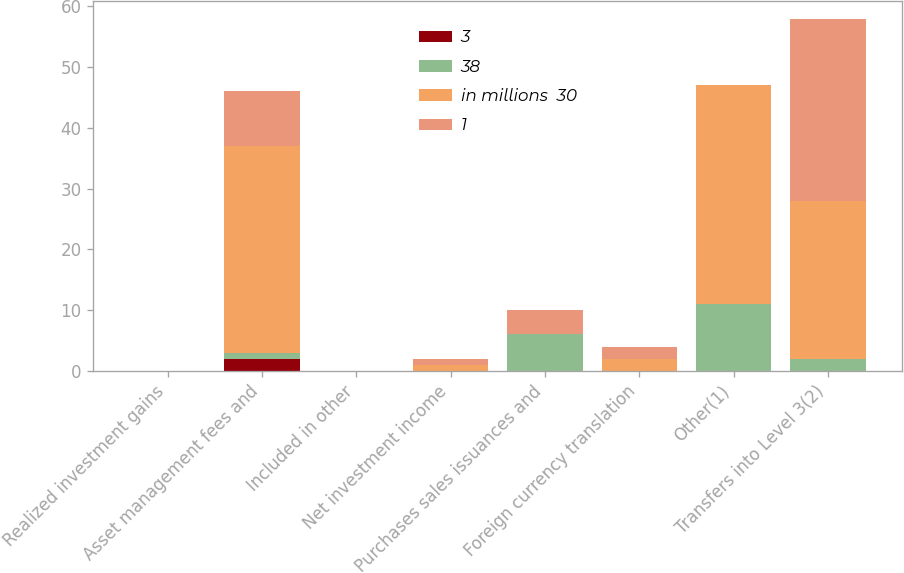Convert chart to OTSL. <chart><loc_0><loc_0><loc_500><loc_500><stacked_bar_chart><ecel><fcel>Realized investment gains<fcel>Asset management fees and<fcel>Included in other<fcel>Net investment income<fcel>Purchases sales issuances and<fcel>Foreign currency translation<fcel>Other(1)<fcel>Transfers into Level 3(2)<nl><fcel>3<fcel>0<fcel>2<fcel>0<fcel>0<fcel>0<fcel>0<fcel>0<fcel>0<nl><fcel>38<fcel>0<fcel>1<fcel>0<fcel>0<fcel>6<fcel>0<fcel>11<fcel>2<nl><fcel>in millions  30<fcel>0<fcel>34<fcel>0<fcel>1<fcel>0<fcel>2<fcel>36<fcel>26<nl><fcel>1<fcel>0<fcel>9<fcel>0<fcel>1<fcel>4<fcel>2<fcel>0<fcel>30<nl></chart> 